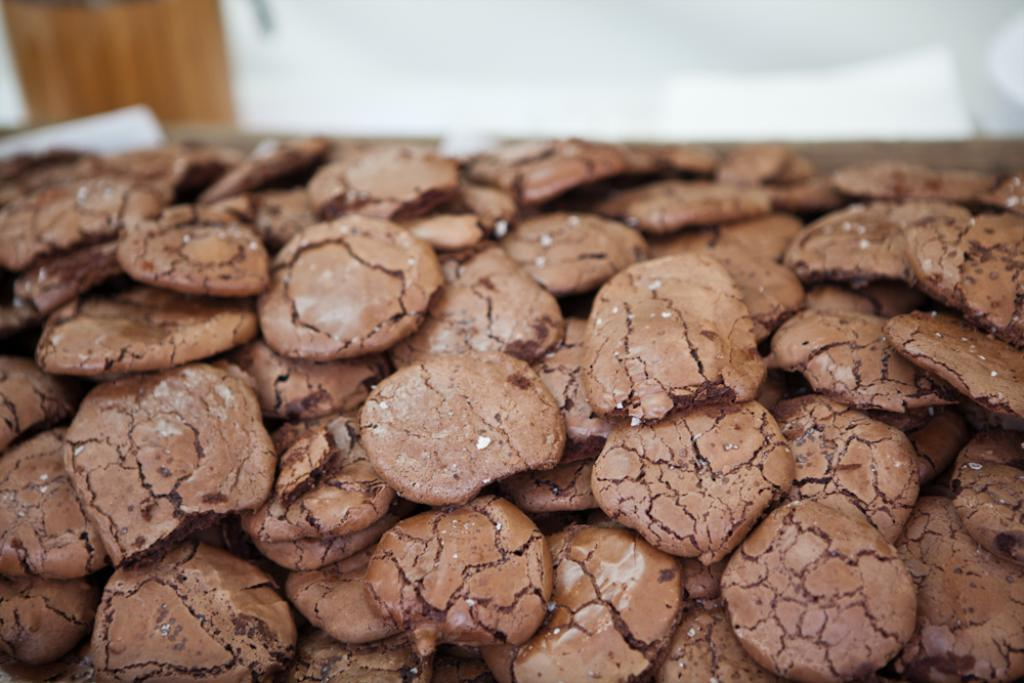What type of food is visible in the image? There are cookies in the image. Where are the cookies located? The cookies are on a surface. Can you describe the background of the image? The background of the image is blurry. What color is the crayon used to draw on the cookies in the image? There is no crayon or drawing on the cookies in the image; they are simply cookies on a surface. 